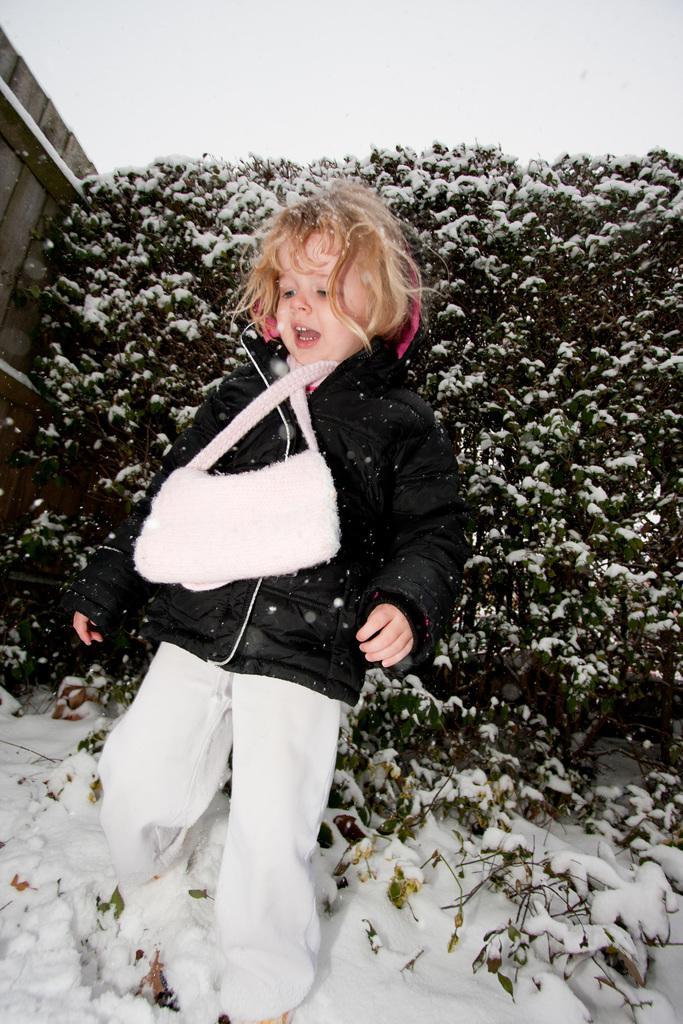Can you describe this image briefly? In this image we can see a child on the snow, there are trees, a wooden fence and the sky in the background. 